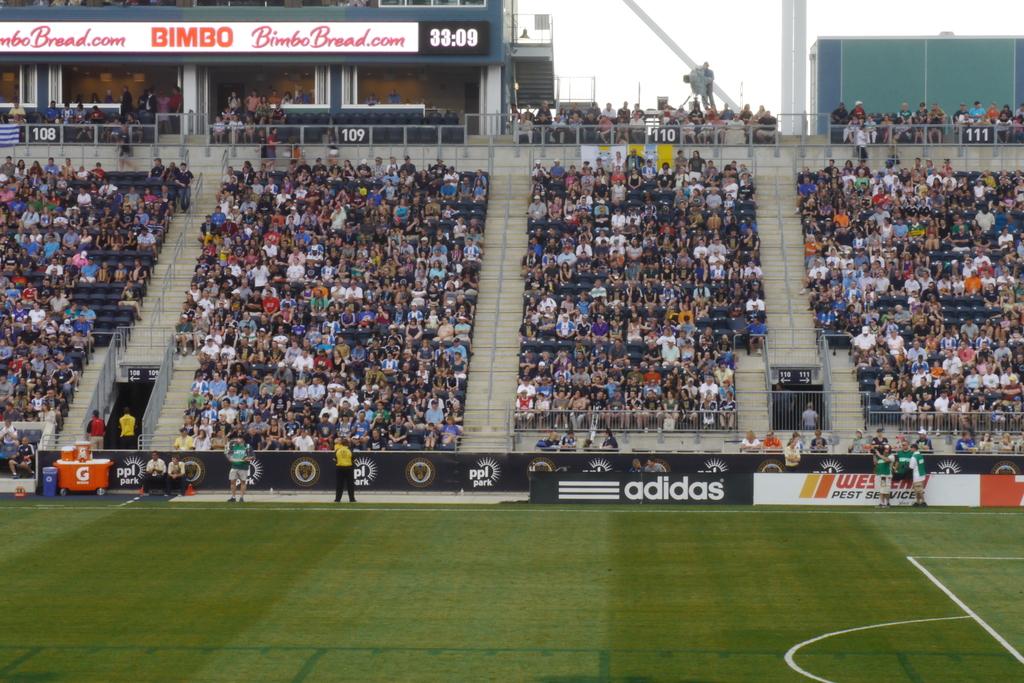What shoe company is advertised here?
Provide a succinct answer. Adidas. 